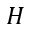<formula> <loc_0><loc_0><loc_500><loc_500>H</formula> 